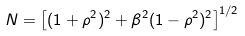Convert formula to latex. <formula><loc_0><loc_0><loc_500><loc_500>N = \left [ ( 1 + \rho ^ { 2 } ) ^ { 2 } + \beta ^ { 2 } ( 1 - \rho ^ { 2 } ) ^ { 2 } \right ] ^ { 1 / 2 }</formula> 